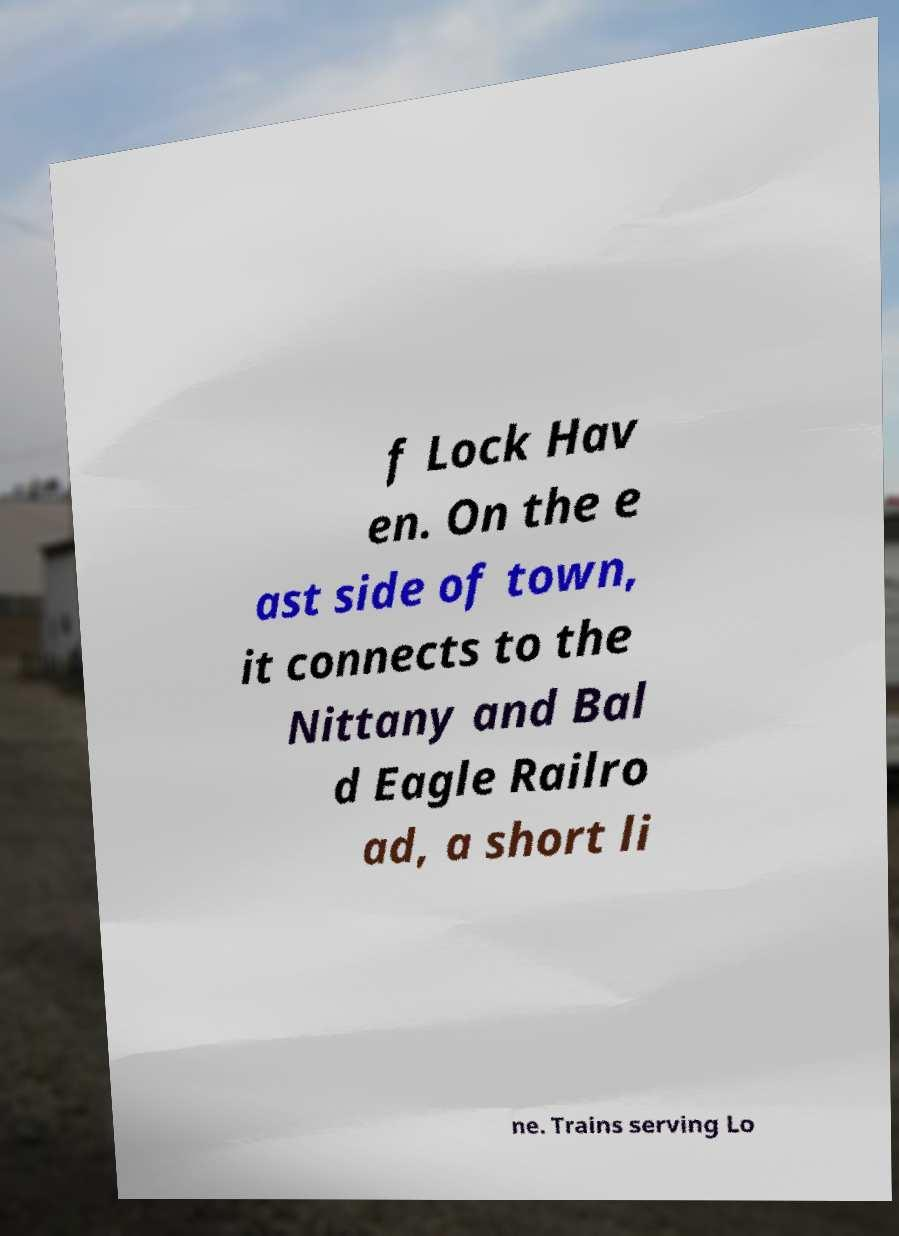For documentation purposes, I need the text within this image transcribed. Could you provide that? f Lock Hav en. On the e ast side of town, it connects to the Nittany and Bal d Eagle Railro ad, a short li ne. Trains serving Lo 